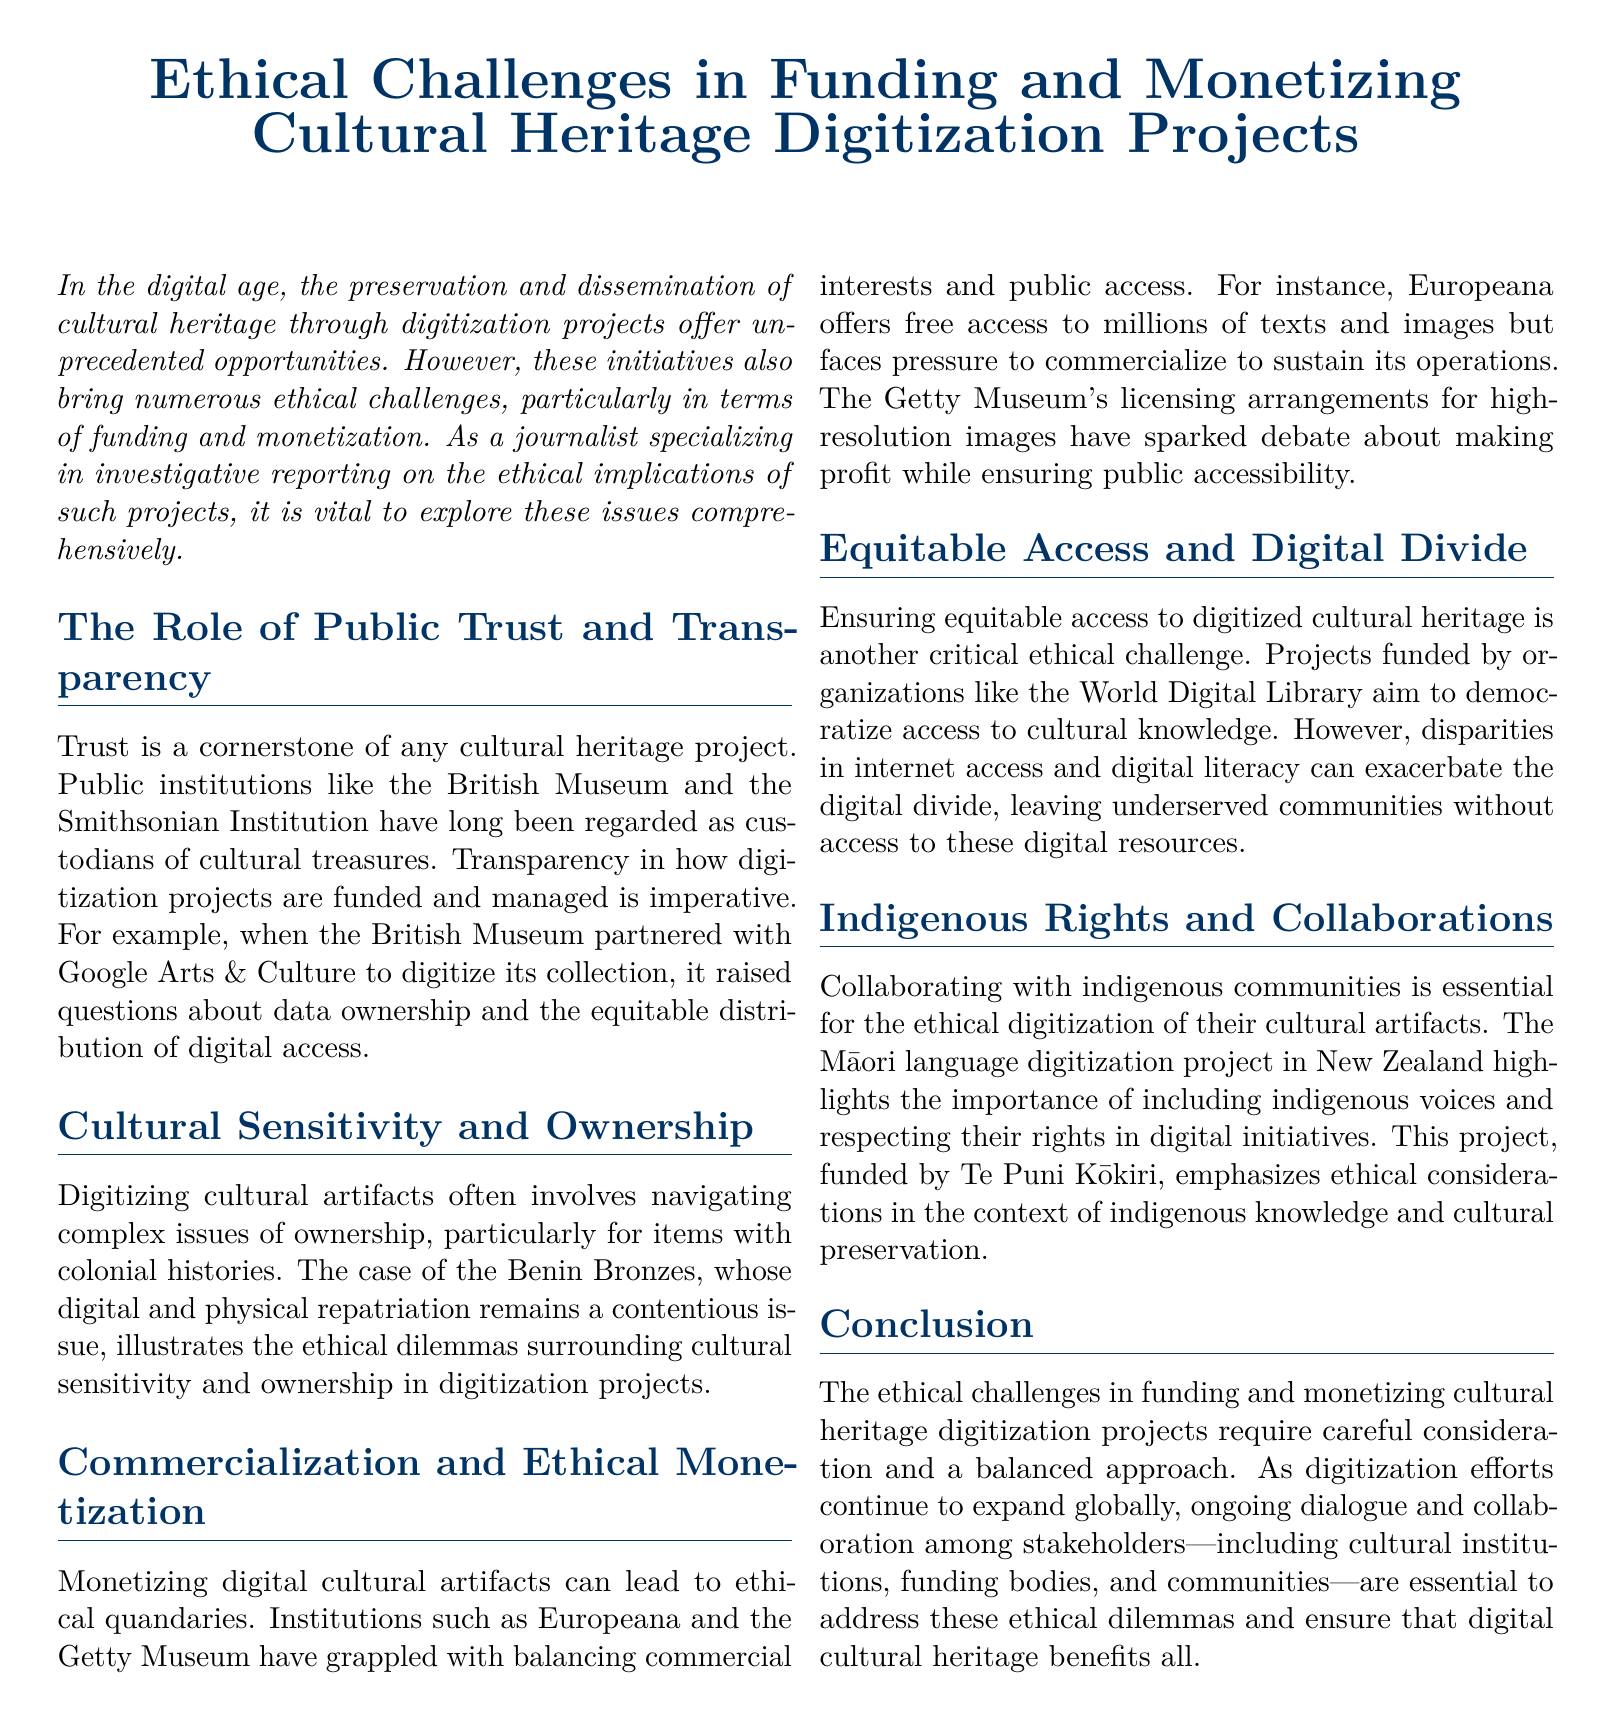What is the title of the document? The title is explicitly stated at the beginning of the document.
Answer: Ethical Challenges in Funding and Monetizing Cultural Heritage Digitization Projects Which institution partnered with Google Arts & Culture? The document mentions a specific institution in relation to a partnership for digitization.
Answer: British Museum What is one of the ethical dilemmas mentioned regarding the Benin Bronzes? The dilemma is related to ownership and colonial histories.
Answer: Cultural sensitivity and ownership Which organization aims to democratize access to cultural knowledge? The document lists an organization focused on equitable access to digitized heritage.
Answer: World Digital Library What is a key issue with digitization projects funded by organizations? The document highlights a critical challenge faced by such projects.
Answer: Digital divide What type of project is funded by Te Puni Kōkiri in New Zealand? The funding-body project is specified in the context of indigenous communities.
Answer: Māori language digitization project Which institution is mentioned as grappling with commercialization and public access? The document refers to a specific institution facing this ethical quandary.
Answer: Getty Museum What is emphasized as essential for collaborating with indigenous communities? The document underlines an important principle in ethical digitization practices.
Answer: Including indigenous voices and respecting their rights What is the conclusion's focus regarding ethical challenges? The conclusion addresses the approach needed to face stated challenges.
Answer: Ongoing dialogue and collaboration among stakeholders 